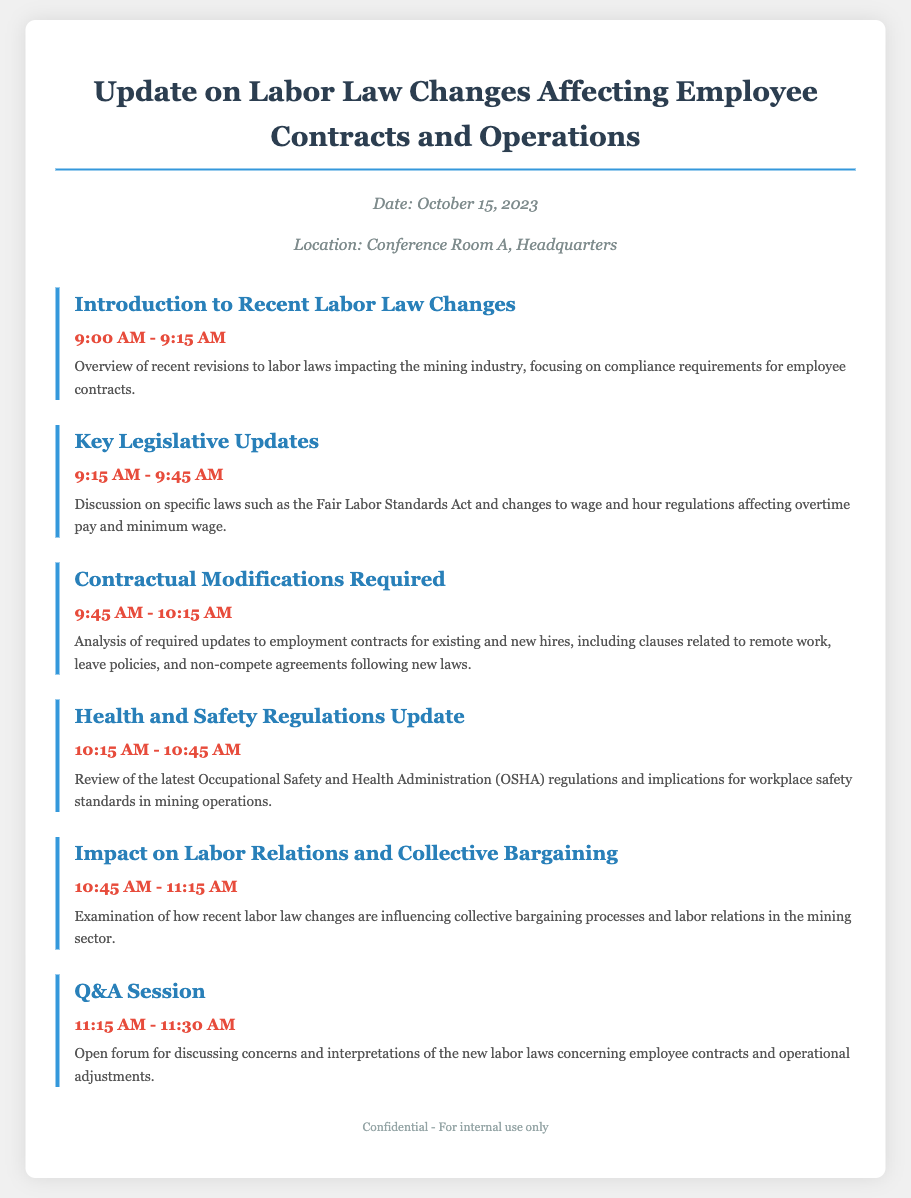What is the date of the meeting? The date of the meeting is explicitly stated in the header information section of the document.
Answer: October 15, 2023 Where is the meeting being held? The location of the meeting is provided in the header information section of the document.
Answer: Conference Room A, Headquarters What is the time for the Introduction to Recent Labor Law Changes? The time for this agenda item is mentioned under the corresponding section in the document.
Answer: 9:00 AM - 9:15 AM Which law is discussed in the Key Legislative Updates section? The document specifies the Fair Labor Standards Act as a key law in this agenda item.
Answer: Fair Labor Standards Act What topic is covered immediately after the Health and Safety Regulations Update? This question requires knowledge of the sequence of agenda items listed in the document.
Answer: Impact on Labor Relations and Collective Bargaining How long is the Q&A session scheduled for? The duration of the Q&A session is provided within the time section of that agenda item.
Answer: 15 minutes What is the overarching theme of the agenda document? The document summarizes the focus on labor law changes and their implications for operations.
Answer: Labor Law Changes Affecting Employee Contracts and Operations What is the last item on the agenda? The final agenda item is listed at the end of the document structure.
Answer: Q&A Session 